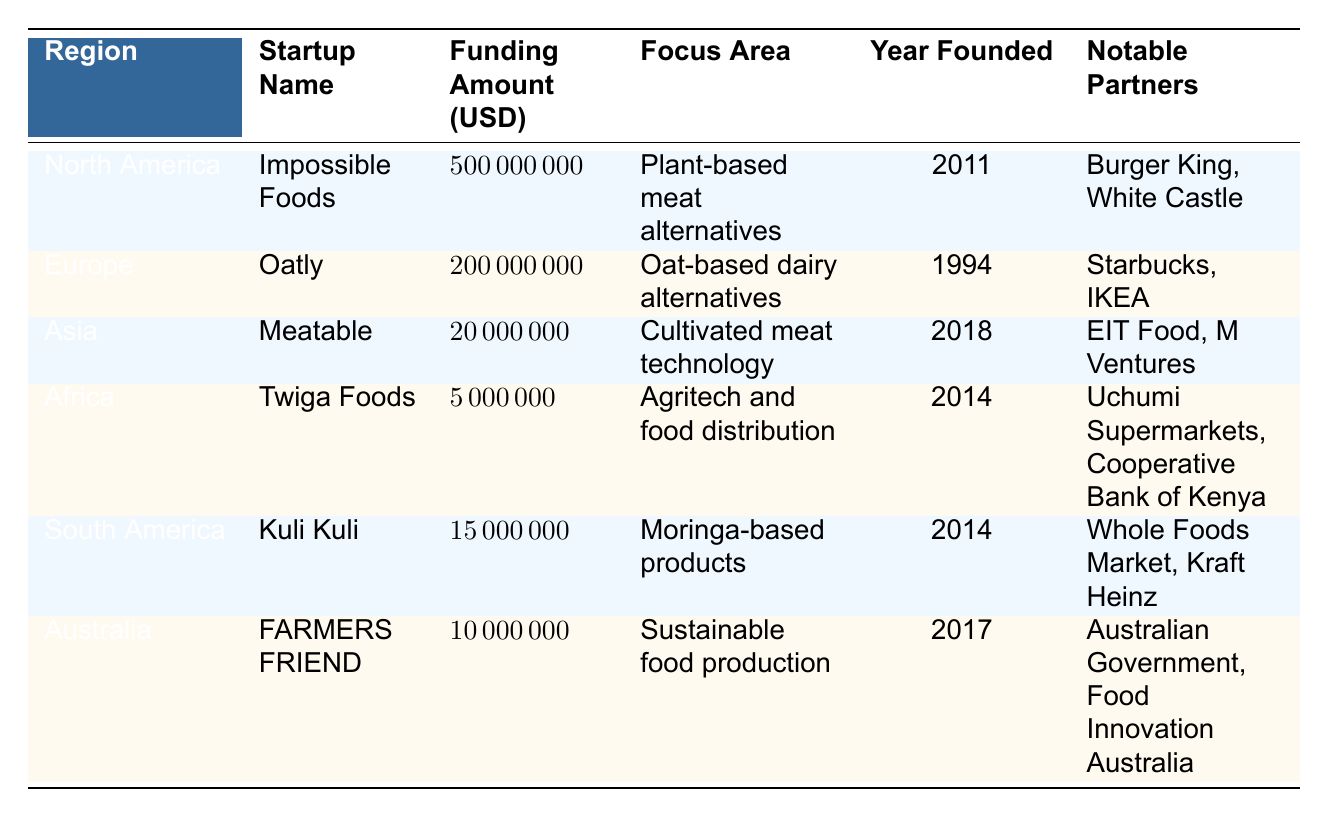What is the startup with the highest funding amount? By examining the "Funding Amount" column in the table, it's clear that Impossible Foods has the highest funding amount of 500 million USD.
Answer: Impossible Foods Which region does Oatly operate in? Oatly is listed under the "Region" column as being based in Europe.
Answer: Europe How much funding did Meatable receive? From the "Funding Amount" column, Meatable is shown to have received 20 million USD in funding.
Answer: 20 million USD What is the average funding amount for startups in Africa and South America? The funding amounts are 5 million USD for Twiga Foods and 15 million USD for Kuli Kuli. The average is calculated as (5 + 15) / 2 = 10 million USD.
Answer: 10 million USD Is FARMERS FRIEND focused on plant-based products? By reviewing the "Focus Area" column, FARMERS FRIEND is focused on sustainable food production, not specifically on plant-based products, making the statement false.
Answer: No Which startup was founded most recently? Checking the "Year Founded" column, Meatable is listed as founded in 2018, which is the most recent year compared to all other startups in the table.
Answer: Meatable Which notable partners does Impossible Foods have? The "Notable Partners" column for Impossible Foods lists Burger King and White Castle as its partners.
Answer: Burger King, White Castle In which year was Kuli Kuli founded? Kuli Kuli is indicated in the "Year Founded" column as being founded in 2014.
Answer: 2014 How does the funding amount of Oatly compare to Twiga Foods? Oatly received 200 million USD while Twiga Foods received 5 million USD, indicating that Oatly's funding is significantly higher by 195 million USD.
Answer: Oatly is higher by 195 million USD What focus area is associated with Kuli Kuli? Looking at the "Focus Area" column, Kuli Kuli focuses on moringa-based products.
Answer: Moringa-based products 